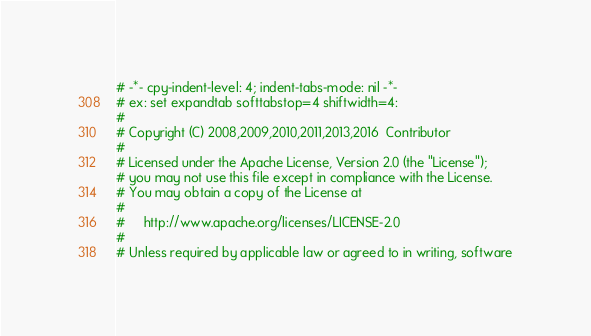<code> <loc_0><loc_0><loc_500><loc_500><_Python_># -*- cpy-indent-level: 4; indent-tabs-mode: nil -*-
# ex: set expandtab softtabstop=4 shiftwidth=4:
#
# Copyright (C) 2008,2009,2010,2011,2013,2016  Contributor
#
# Licensed under the Apache License, Version 2.0 (the "License");
# you may not use this file except in compliance with the License.
# You may obtain a copy of the License at
#
#     http://www.apache.org/licenses/LICENSE-2.0
#
# Unless required by applicable law or agreed to in writing, software</code> 